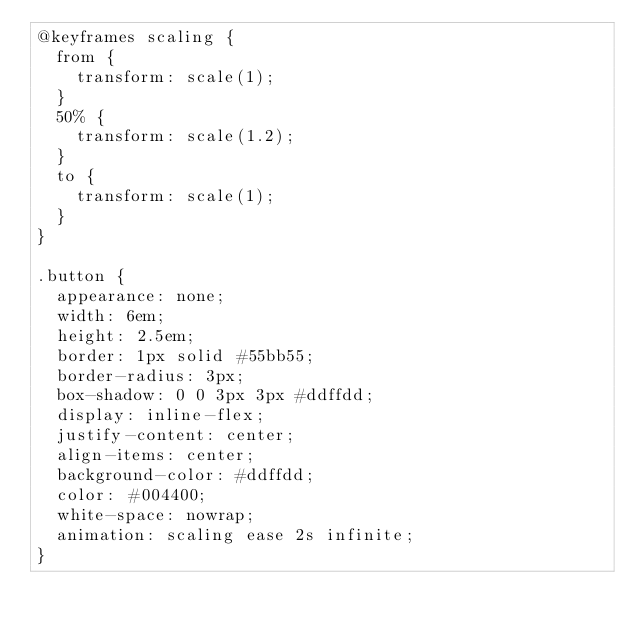Convert code to text. <code><loc_0><loc_0><loc_500><loc_500><_CSS_>@keyframes scaling {
  from {
    transform: scale(1);
  }
  50% {
    transform: scale(1.2);
  }
  to {
    transform: scale(1);
  }
}

.button {
  appearance: none;
  width: 6em;
  height: 2.5em;
  border: 1px solid #55bb55;
  border-radius: 3px;
  box-shadow: 0 0 3px 3px #ddffdd;
  display: inline-flex;
  justify-content: center;
  align-items: center;
  background-color: #ddffdd;
  color: #004400;
  white-space: nowrap;
  animation: scaling ease 2s infinite;
}
</code> 